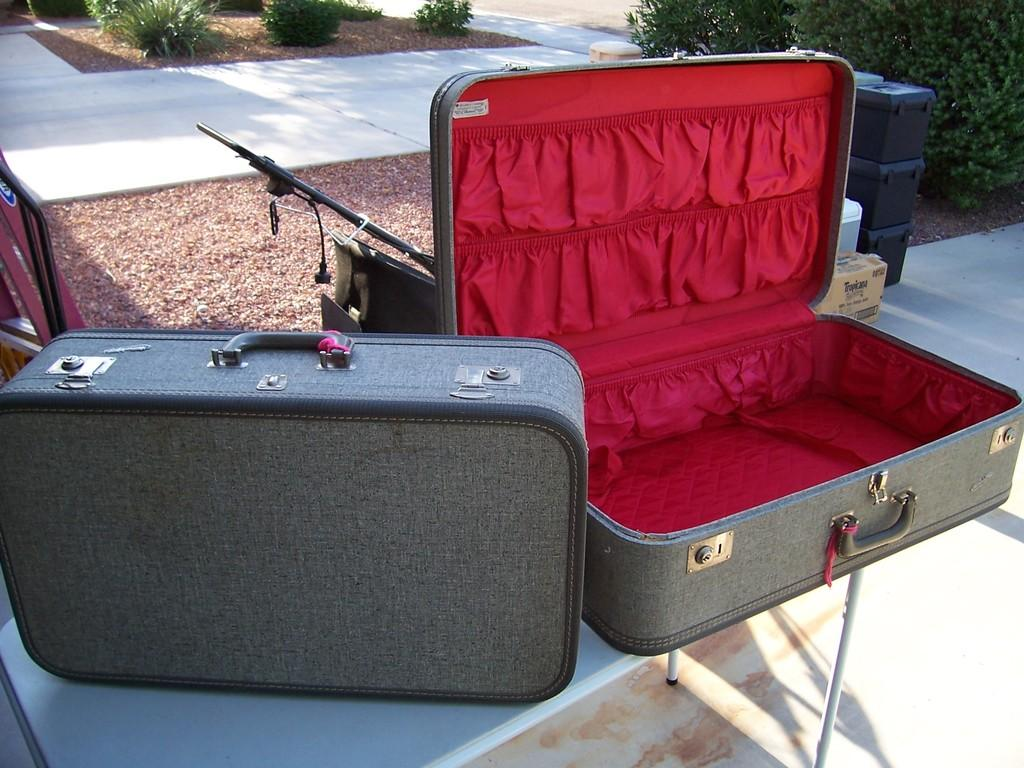What objects are on the table in the image? There are two suitcases on the table. How can the suitcases be carried? The suitcases have handles for carrying. What is located on the left side of the image? There are three boxes on the left side. What type of vegetation is present in the image? There are plants in the image. What can be seen in the image that might be used for walking? There is a walkway in the image. Can you see any dinosaurs walking on the walkway in the image? No, there are no dinosaurs present in the image. What color is the spot on the walkway in the image? There is no spot on the walkway in the image. 